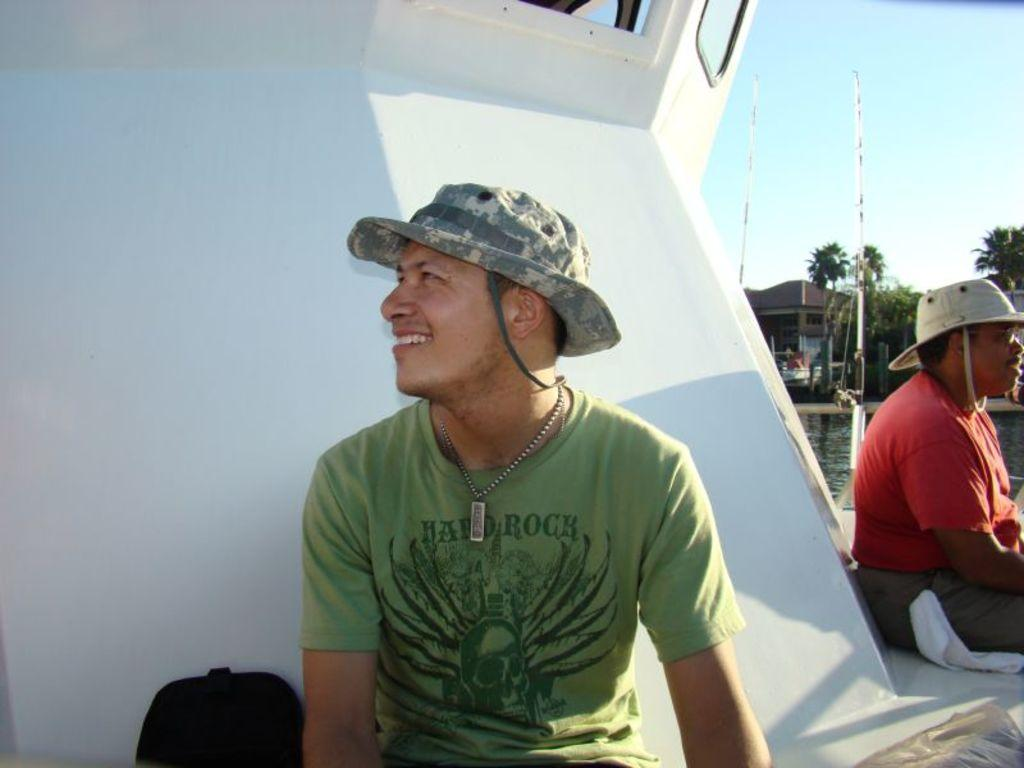How many people are in the image? There are two people in the image. What are the people wearing on their heads? The people are wearing hats. Where are the people sitting in the image? The people are sitting on a ship. What can be seen in the background of the image? There is water, trees, houses, a pole, and the sky visible in the background of the image. Reasoning: Let's step by step to produce the conversation. We start by identifying the number of people in the image, which is two. Then, we describe the clothing or accessories they are wearing, which are hats. Next, we focus on the location of the people, which is on a ship. Finally, we expand the conversation to include the background elements, such as water, trees, houses, a pole, and the sky. Each question is designed to elicit a specific detail about the image that is known from the provided facts. Absurd Question/Answer: What type of dust can be seen in the image? There is no dust present in the image. Are the people in the image engaged in a fight? The image does not depict any fighting or conflict between the people. 